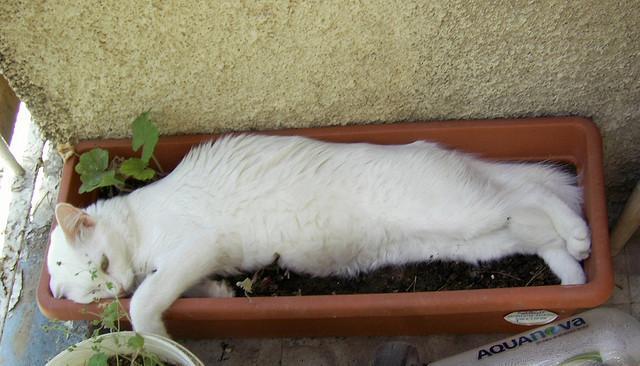How many potted plants are there?
Give a very brief answer. 2. 